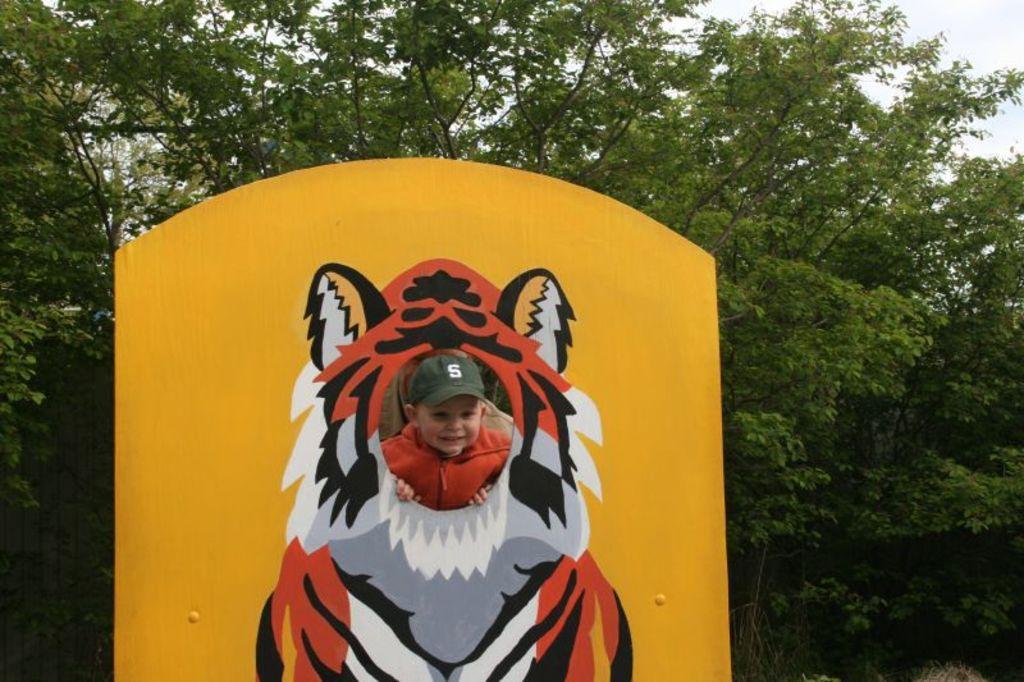How would you summarize this image in a sentence or two? There is a drawing picture of a tiger on the board as we can see at the bottom of this image. We can see a child in the middle and there are trees in the background. 